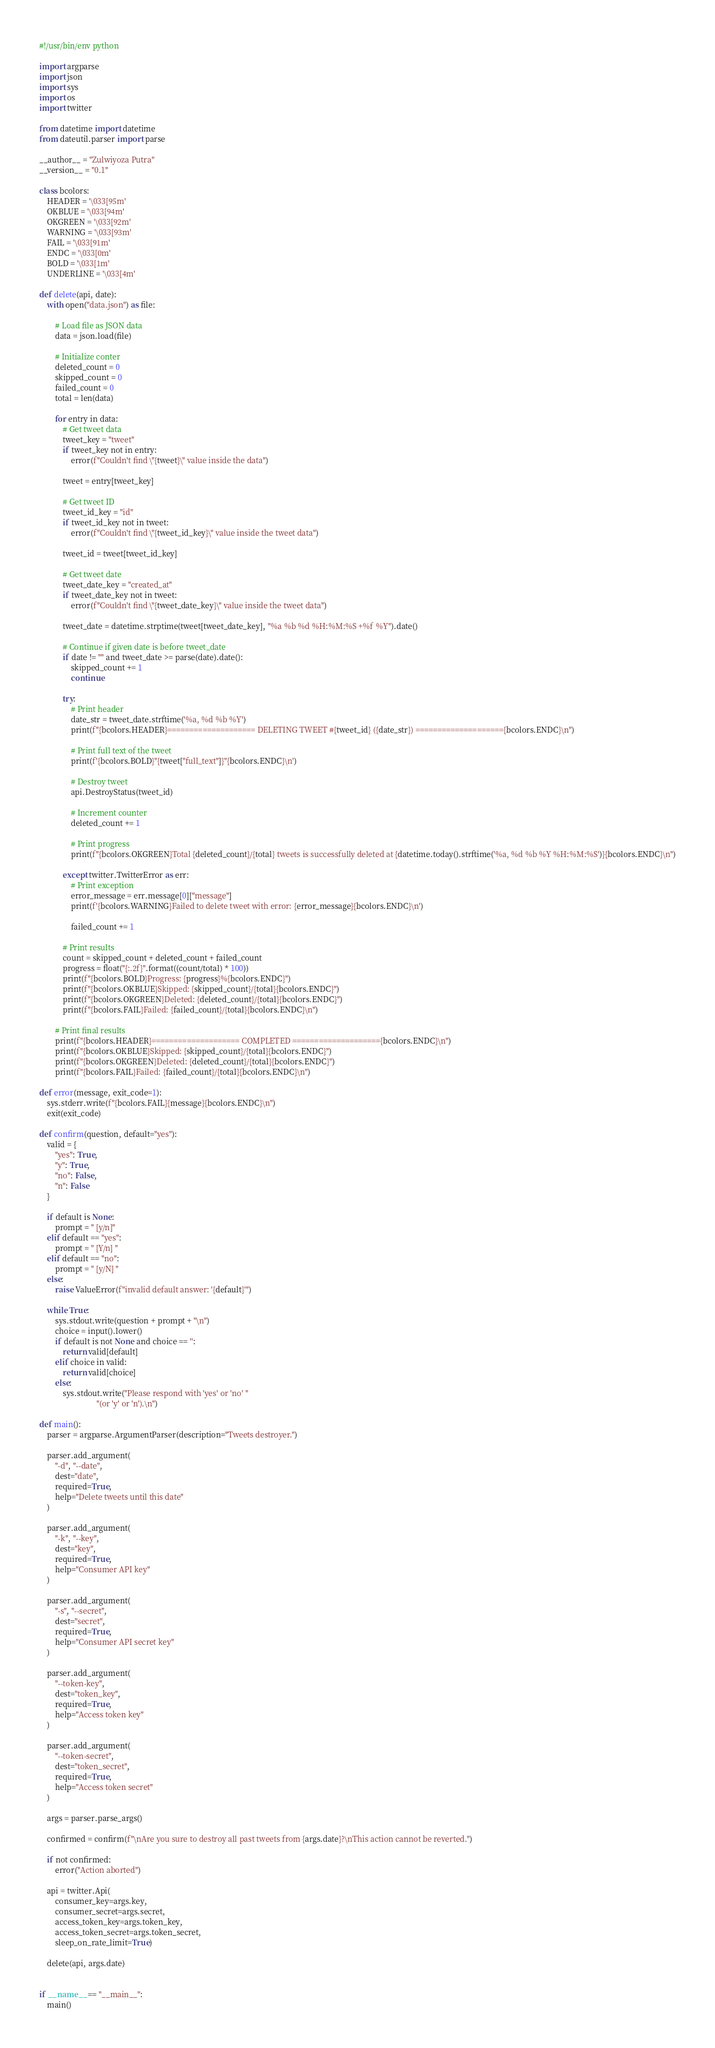Convert code to text. <code><loc_0><loc_0><loc_500><loc_500><_Python_>#!/usr/bin/env python

import argparse
import json
import sys
import os
import twitter

from datetime import datetime
from dateutil.parser import parse

__author__ = "Zulwiyoza Putra"
__version__ = "0.1"

class bcolors:
    HEADER = '\033[95m'
    OKBLUE = '\033[94m'
    OKGREEN = '\033[92m'
    WARNING = '\033[93m'
    FAIL = '\033[91m'
    ENDC = '\033[0m'
    BOLD = '\033[1m'
    UNDERLINE = '\033[4m'

def delete(api, date):
    with open("data.json") as file:

        # Load file as JSON data
        data = json.load(file)

        # Initialize conter
        deleted_count = 0
        skipped_count = 0
        failed_count = 0
        total = len(data)

        for entry in data:
            # Get tweet data
            tweet_key = "tweet"
            if tweet_key not in entry:
                error(f"Couldn't find \"{tweet}\" value inside the data")
            
            tweet = entry[tweet_key]

            # Get tweet ID
            tweet_id_key = "id"
            if tweet_id_key not in tweet:
                error(f"Couldn't find \"{tweet_id_key}\" value inside the tweet data")

            tweet_id = tweet[tweet_id_key]

            # Get tweet date
            tweet_date_key = "created_at"
            if tweet_date_key not in tweet:
                error(f"Couldn't find \"{tweet_date_key}\" value inside the tweet data")

            tweet_date = datetime.strptime(tweet[tweet_date_key], "%a %b %d %H:%M:%S +%f %Y").date()

            # Continue if given date is before tweet_date
            if date != "" and tweet_date >= parse(date).date():
                skipped_count += 1
                continue

            try:
                # Print header
                date_str = tweet_date.strftime('%a, %d %b %Y')
                print(f"{bcolors.HEADER}==================== DELETING TWEET #{tweet_id} ({date_str}) ===================={bcolors.ENDC}\n")

                # Print full text of the tweet
                print(f'{bcolors.BOLD}"{tweet["full_text"]}"{bcolors.ENDC}\n')

                # Destroy tweet
                api.DestroyStatus(tweet_id)

                # Increment counter
                deleted_count += 1

                # Print progress
                print(f"{bcolors.OKGREEN}Total {deleted_count}/{total} tweets is successfully deleted at {datetime.today().strftime('%a, %d %b %Y %H:%M:%S')}{bcolors.ENDC}\n")

            except twitter.TwitterError as err:
                # Print exception
                error_message = err.message[0]["message"]
                print(f'{bcolors.WARNING}Failed to delete tweet with error: {error_message}{bcolors.ENDC}\n')

                failed_count += 1

            # Print results
            count = skipped_count + deleted_count + failed_count
            progress = float("{:.2f}".format((count/total) * 100))
            print(f"{bcolors.BOLD}Progress: {progress}%{bcolors.ENDC}")
            print(f"{bcolors.OKBLUE}Skipped: {skipped_count}/{total}{bcolors.ENDC}")
            print(f"{bcolors.OKGREEN}Deleted: {deleted_count}/{total}{bcolors.ENDC}")
            print(f"{bcolors.FAIL}Failed: {failed_count}/{total}{bcolors.ENDC}\n")
        
        # Print final results
        print(f"{bcolors.HEADER}==================== COMPLETED ===================={bcolors.ENDC}\n")
        print(f"{bcolors.OKBLUE}Skipped: {skipped_count}/{total}{bcolors.ENDC}")
        print(f"{bcolors.OKGREEN}Deleted: {deleted_count}/{total}{bcolors.ENDC}")
        print(f"{bcolors.FAIL}Failed: {failed_count}/{total}{bcolors.ENDC}\n")
        
def error(message, exit_code=1):
    sys.stderr.write(f"{bcolors.FAIL}{message}{bcolors.ENDC}\n")
    exit(exit_code)

def confirm(question, default="yes"):
    valid = {
        "yes": True,
        "y": True,
        "no": False,
        "n": False
    }

    if default is None:
        prompt = " [y/n]"
    elif default == "yes":
        prompt = " [Y/n] "
    elif default == "no":
        prompt = " [y/N] "
    else:
        raise ValueError(f"invalid default answer: '{default}'")

    while True:
        sys.stdout.write(question + prompt + "\n")
        choice = input().lower()
        if default is not None and choice == '':
            return valid[default]
        elif choice in valid:
            return valid[choice]
        else:
            sys.stdout.write("Please respond with 'yes' or 'no' "
                             "(or 'y' or 'n').\n")

def main():
    parser = argparse.ArgumentParser(description="Tweets destroyer.")

    parser.add_argument(
        "-d", "--date", 
        dest="date", 
        required=True,
        help="Delete tweets until this date"
    )

    parser.add_argument(
        "-k", "--key", 
        dest="key", 
        required=True,
        help="Consumer API key"
    )

    parser.add_argument(
        "-s", "--secret", 
        dest="secret", 
        required=True,
        help="Consumer API secret key"
    )

    parser.add_argument(
        "--token-key", 
        dest="token_key", 
        required=True,
        help="Access token key"
    )

    parser.add_argument(
        "--token-secret", 
        dest="token_secret", 
        required=True,
        help="Access token secret"
    )

    args = parser.parse_args()

    confirmed = confirm(f"\nAre you sure to destroy all past tweets from {args.date}?\nThis action cannot be reverted.")

    if not confirmed:
        error("Action aborted")

    api = twitter.Api(
        consumer_key=args.key,
        consumer_secret=args.secret,
        access_token_key=args.token_key,
        access_token_secret=args.token_secret,
        sleep_on_rate_limit=True)
    
    delete(api, args.date)


if __name__ == "__main__":
    main()
</code> 